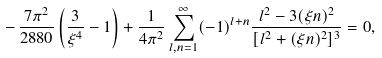<formula> <loc_0><loc_0><loc_500><loc_500>- \, \frac { 7 \pi ^ { 2 } } { 2 8 8 0 } \left ( \frac { 3 } { \xi ^ { 4 } } - 1 \right ) + \frac { 1 } { 4 \pi ^ { 2 } } \sum _ { l , n = 1 } ^ { \infty } ( - 1 ) ^ { l + n } \frac { l ^ { 2 } - 3 ( \xi n ) ^ { 2 } } { [ l ^ { 2 } + ( \xi n ) ^ { 2 } ] ^ { 3 } } = 0 ,</formula> 